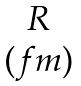<formula> <loc_0><loc_0><loc_500><loc_500>\begin{matrix} R \\ ( f m ) \end{matrix}</formula> 